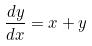<formula> <loc_0><loc_0><loc_500><loc_500>\frac { d y } { d x } = x + y</formula> 